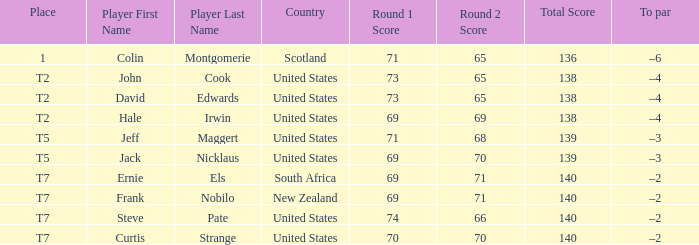What is the name of the golfer that has the score of 73-65=138? John Cook, David Edwards. 